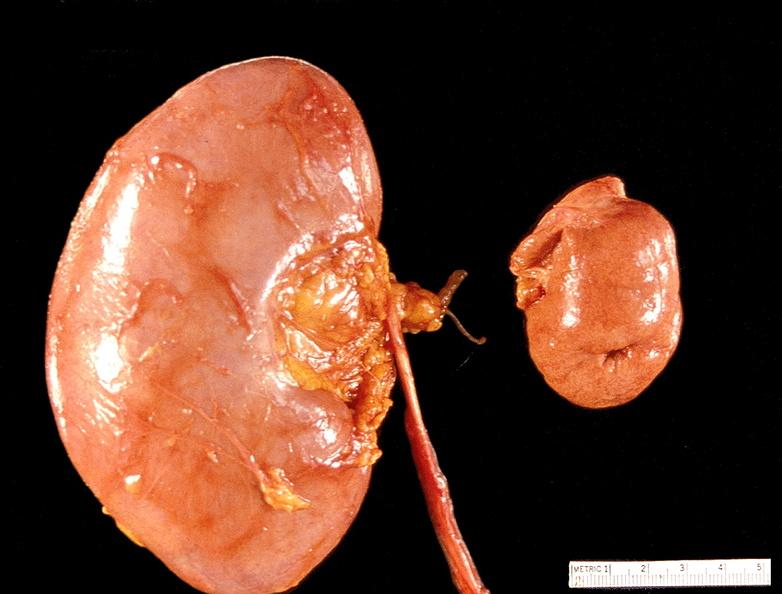where is this?
Answer the question using a single word or phrase. Urinary 